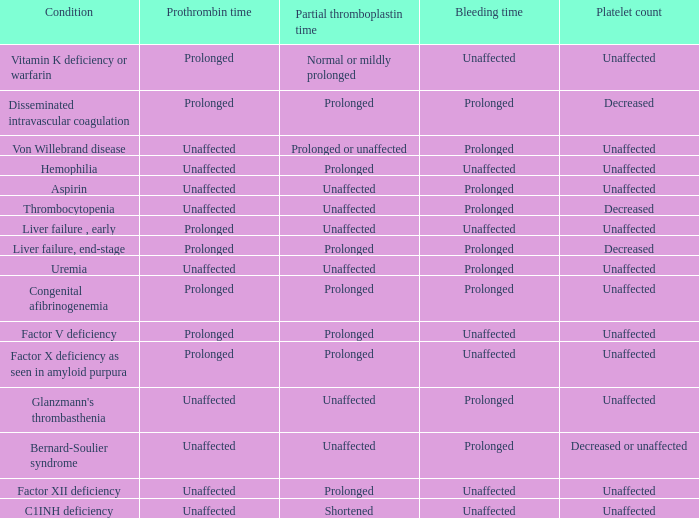What is the partial thromboplastin time in early liver failure conditions? Unaffected. 